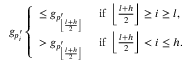<formula> <loc_0><loc_0><loc_500><loc_500>g _ { p _ { i } ^ { \prime } } \left \{ \begin{array} { l l } { \leq g _ { p _ { \left \lfloor \frac { l + h } { 2 } \right \rfloor } ^ { \prime } } \quad i f \left \lfloor \frac { l + h } { 2 } \right \rfloor \geq i \geq l , } \\ { > g _ { p _ { \left \lfloor \frac { l + h } { 2 } \right \rfloor } ^ { \prime } } \quad i f \left \lfloor \frac { l + h } { 2 } \right \rfloor < i \leq h . } \end{array}</formula> 